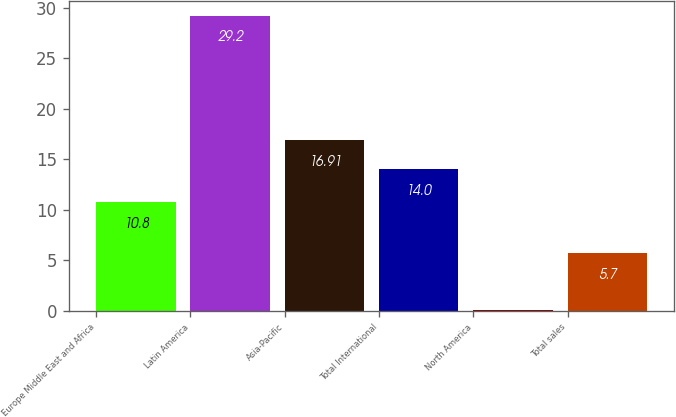Convert chart. <chart><loc_0><loc_0><loc_500><loc_500><bar_chart><fcel>Europe Middle East and Africa<fcel>Latin America<fcel>Asia-Pacific<fcel>Total International<fcel>North America<fcel>Total sales<nl><fcel>10.8<fcel>29.2<fcel>16.91<fcel>14<fcel>0.1<fcel>5.7<nl></chart> 